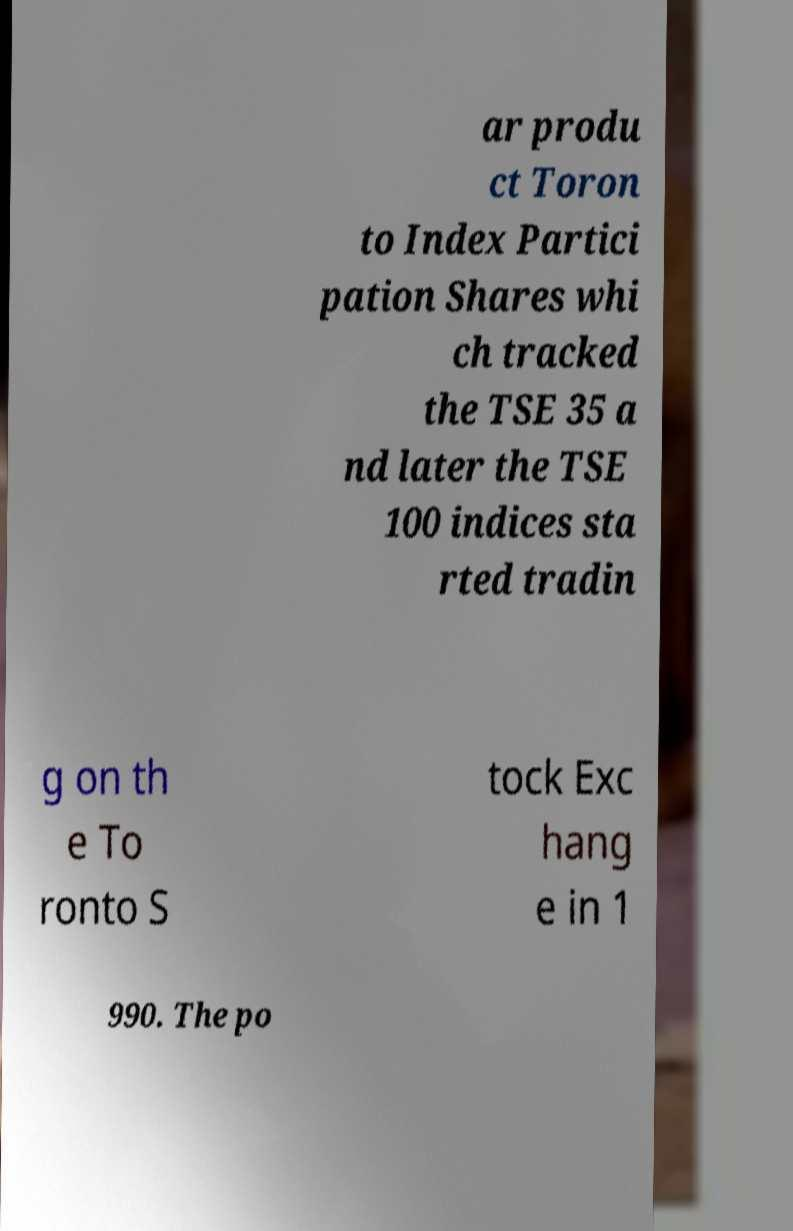Can you read and provide the text displayed in the image?This photo seems to have some interesting text. Can you extract and type it out for me? ar produ ct Toron to Index Partici pation Shares whi ch tracked the TSE 35 a nd later the TSE 100 indices sta rted tradin g on th e To ronto S tock Exc hang e in 1 990. The po 